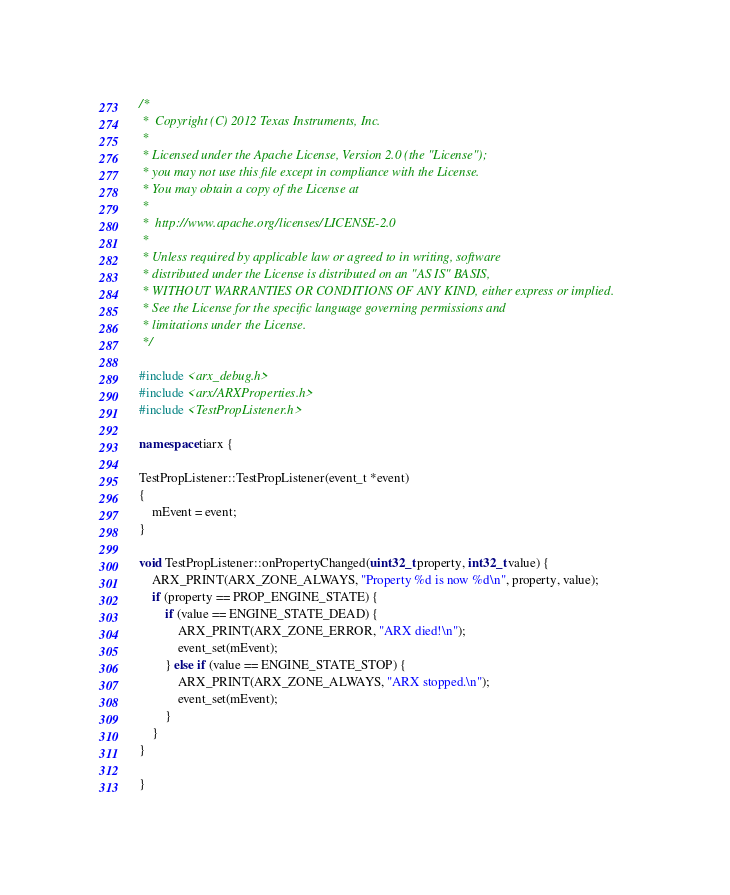Convert code to text. <code><loc_0><loc_0><loc_500><loc_500><_C++_>/*
 *  Copyright (C) 2012 Texas Instruments, Inc.
 *
 * Licensed under the Apache License, Version 2.0 (the "License");
 * you may not use this file except in compliance with the License.
 * You may obtain a copy of the License at
 *
 *  http://www.apache.org/licenses/LICENSE-2.0
 *
 * Unless required by applicable law or agreed to in writing, software
 * distributed under the License is distributed on an "AS IS" BASIS,
 * WITHOUT WARRANTIES OR CONDITIONS OF ANY KIND, either express or implied.
 * See the License for the specific language governing permissions and
 * limitations under the License.
 */

#include <arx_debug.h>
#include <arx/ARXProperties.h>
#include <TestPropListener.h>

namespace tiarx {

TestPropListener::TestPropListener(event_t *event)
{
    mEvent = event;
}

void TestPropListener::onPropertyChanged(uint32_t property, int32_t value) {
    ARX_PRINT(ARX_ZONE_ALWAYS, "Property %d is now %d\n", property, value);
    if (property == PROP_ENGINE_STATE) {
        if (value == ENGINE_STATE_DEAD) {
            ARX_PRINT(ARX_ZONE_ERROR, "ARX died!\n");
            event_set(mEvent);
        } else if (value == ENGINE_STATE_STOP) {
            ARX_PRINT(ARX_ZONE_ALWAYS, "ARX stopped.\n");
            event_set(mEvent);
        }
    }
}

}
</code> 